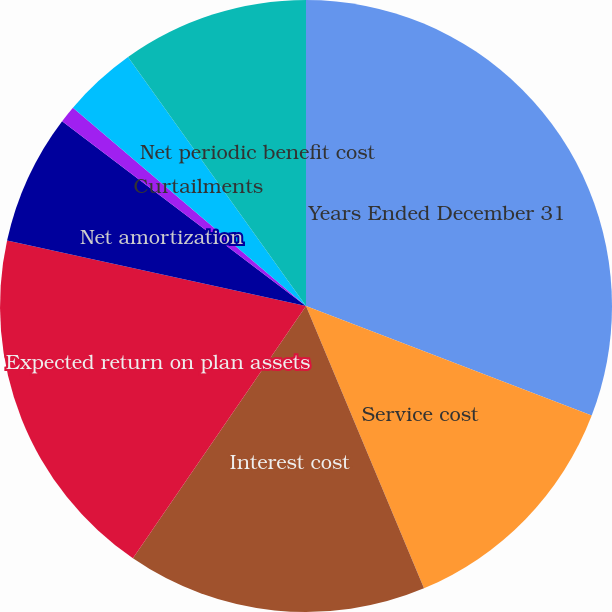Convert chart to OTSL. <chart><loc_0><loc_0><loc_500><loc_500><pie_chart><fcel>Years Ended December 31<fcel>Service cost<fcel>Interest cost<fcel>Expected return on plan assets<fcel>Net amortization<fcel>Termination benefits<fcel>Curtailments<fcel>Net periodic benefit cost<nl><fcel>30.83%<fcel>12.87%<fcel>15.87%<fcel>18.86%<fcel>6.89%<fcel>0.9%<fcel>3.9%<fcel>9.88%<nl></chart> 